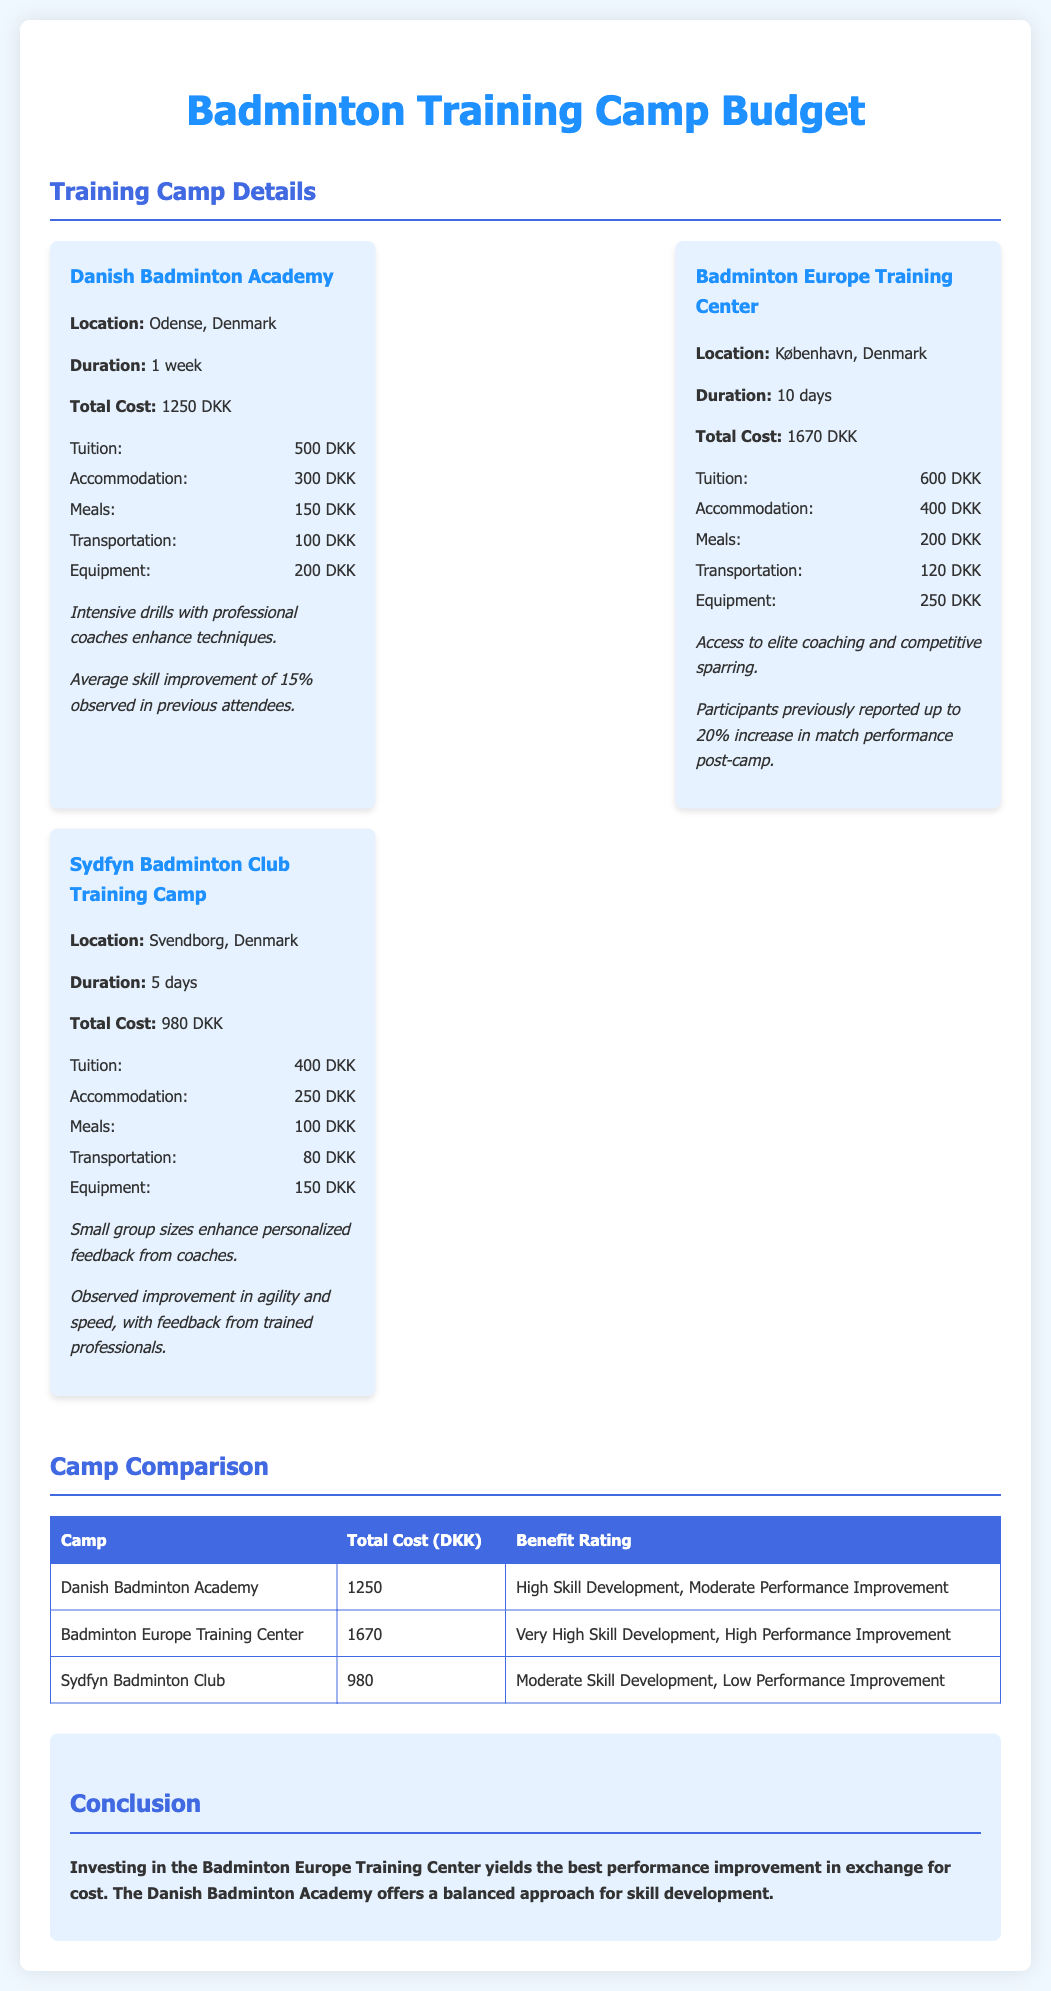what is the total cost of the Danish Badminton Academy? The total cost for this camp is stated directly in the document, which is 1250 DKK.
Answer: 1250 DKK how long is the training camp at the Badminton Europe Training Center? The duration of the training camp is explicitly mentioned as 10 days.
Answer: 10 days what is the main benefit of attending the Sydfyn Badminton Club Training Camp? The document lists that small group sizes enhance personalized feedback from coaches as the main benefit.
Answer: Personalized feedback which camp has the highest reported skill development? The comparison table indicates that the Badminton Europe Training Center has very high skill development.
Answer: Badminton Europe Training Center what is the total cost of the Sydfyn Badminton Club Training Camp? The document specifies the total cost for this camp as 980 DKK.
Answer: 980 DKK according to the document, what percentage skill improvement was observed at the Danish Badminton Academy? It mentions an average skill improvement of 15% observed in previous attendees at this academy.
Answer: 15% which camp offers access to elite coaching and competitive sparring? The document states that the Benefits section for the Badminton Europe Training Center mentions access to elite coaching and competitive sparring.
Answer: Badminton Europe Training Center what are the total costs for the listed training camps? The total costs provided in the camp cards are 1250 DKK, 1670 DKK, and 980 DKK.
Answer: 1250 DKK, 1670 DKK, 980 DKK which camp is considered to have a moderate skill development and low performance improvement? The comparison section identifies that the Sydfyn Badminton Club has moderate skill development and low performance improvement.
Answer: Sydfyn Badminton Club 